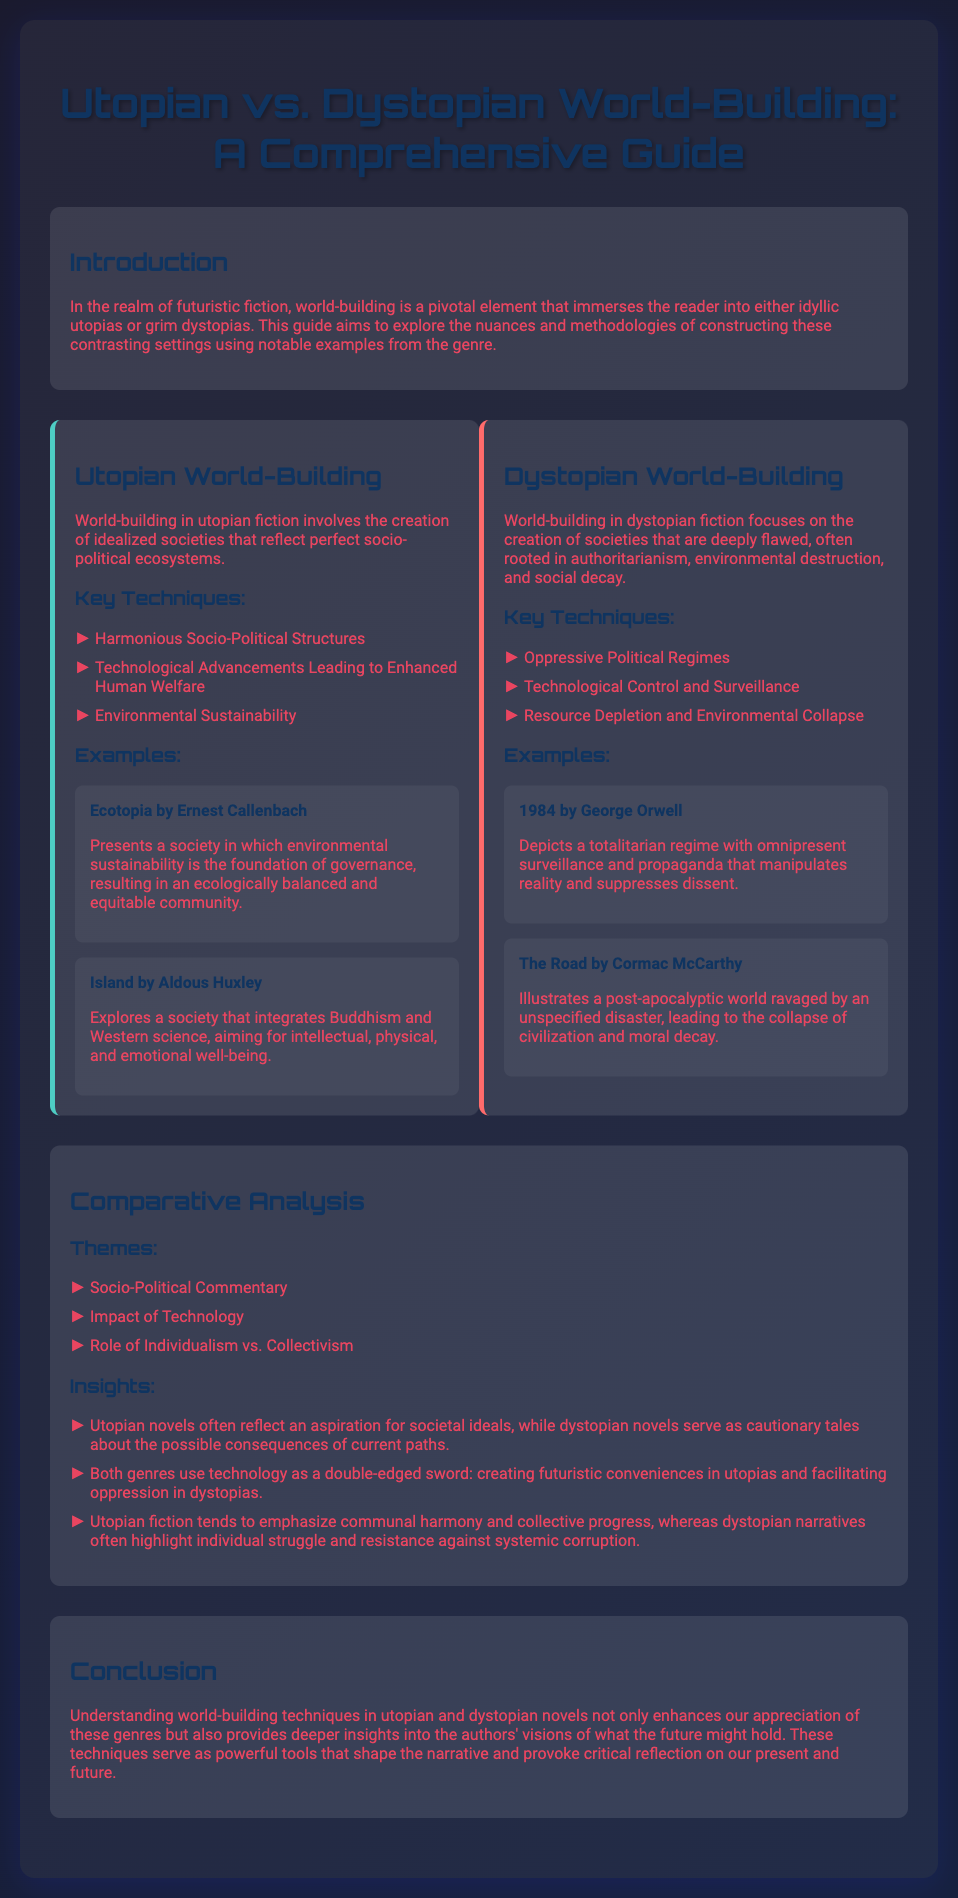What is the main focus of world-building in utopian fiction? The document states that world-building in utopian fiction focuses on creating idealized societies that reflect perfect socio-political ecosystems.
Answer: Idealized societies What novel features a society founded on environmental sustainability? The document lists "Ecotopia by Ernest Callenbach" as a book that presents a society focused on environmental sustainability.
Answer: Ecotopia What political regime is depicted in "1984" by George Orwell? According to the document, "1984" showcases a totalitarian regime characterized by omnipresent surveillance and propaganda.
Answer: Totalitarian regime What is a key technique used in dystopian world-building? The document lists "Oppressive Political Regimes" as a key technique used in dystopian world-building.
Answer: Oppressive Political Regimes How do utopian and dystopian novels view technology? The document explains that both genres use technology as a double-edged sword: creating conveniences in utopias and facilitating oppression in dystopias.
Answer: Double-edged sword What health integration is explored in "Island" by Aldous Huxley? The document refers to "Island" as integrating Buddhism and Western science for well-being.
Answer: Buddhism and Western science What theme addresses the concept of individual versus collective in these narratives? The document states that the role of "Individualism vs. Collectivism" is one of the key themes covered in the comparative analysis.
Answer: Individualism vs. Collectivism Which characteristic is highlighted in utopian fiction compared to dystopian narratives? The document highlights that utopian fiction tends to emphasize "communal harmony and collective progress," contrasting with dystopian narratives.
Answer: Communal harmony 